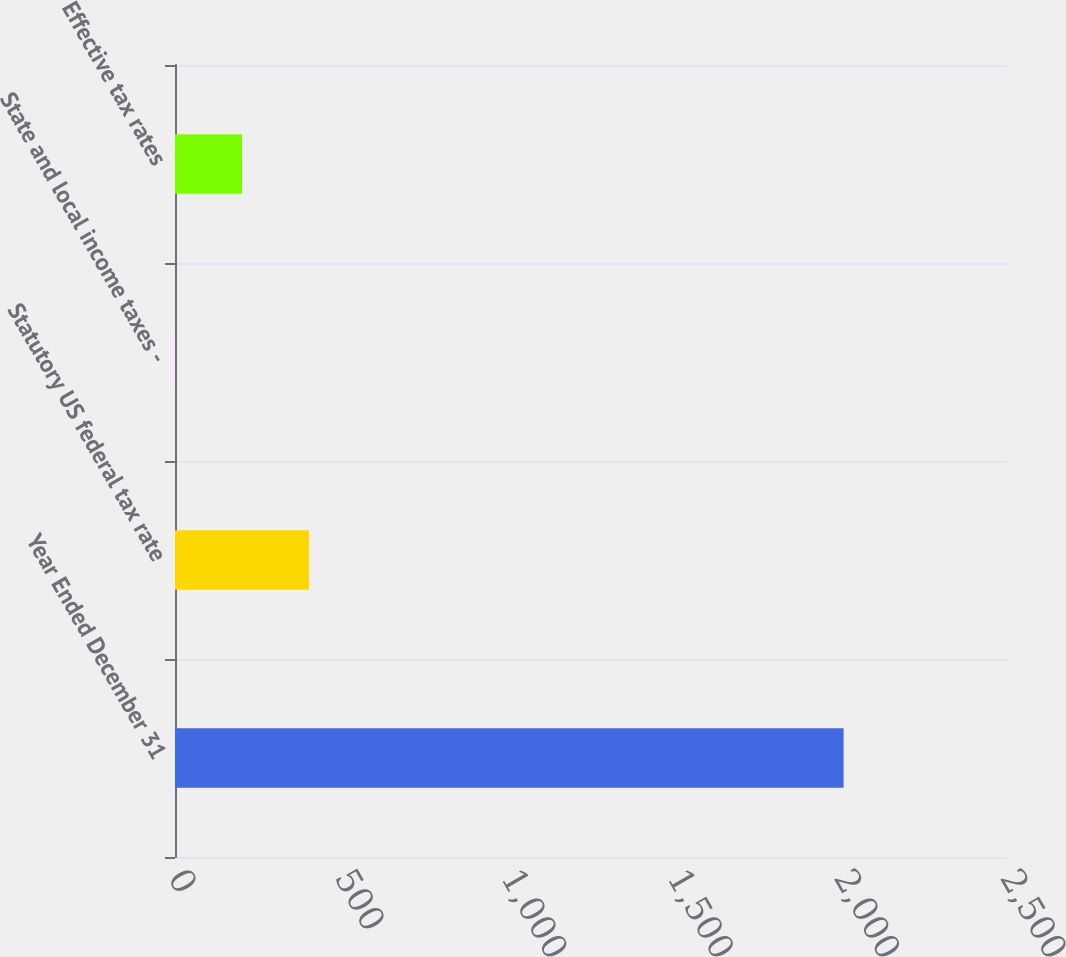Convert chart to OTSL. <chart><loc_0><loc_0><loc_500><loc_500><bar_chart><fcel>Year Ended December 31<fcel>Statutory US federal tax rate<fcel>State and local income taxes -<fcel>Effective tax rates<nl><fcel>2009<fcel>402.36<fcel>0.7<fcel>201.53<nl></chart> 